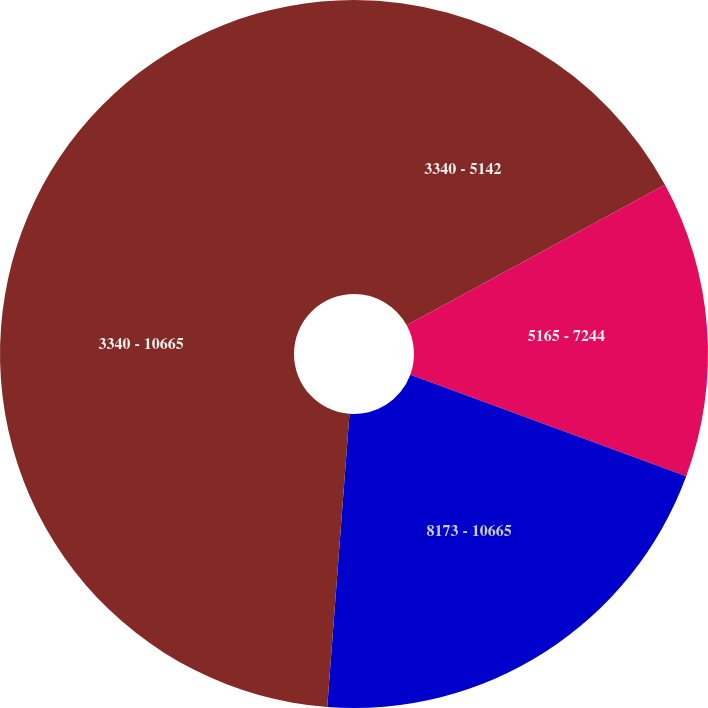<chart> <loc_0><loc_0><loc_500><loc_500><pie_chart><fcel>3340 - 5142<fcel>5165 - 7244<fcel>8173 - 10665<fcel>3340 - 10665<nl><fcel>17.07%<fcel>13.54%<fcel>20.59%<fcel>48.79%<nl></chart> 